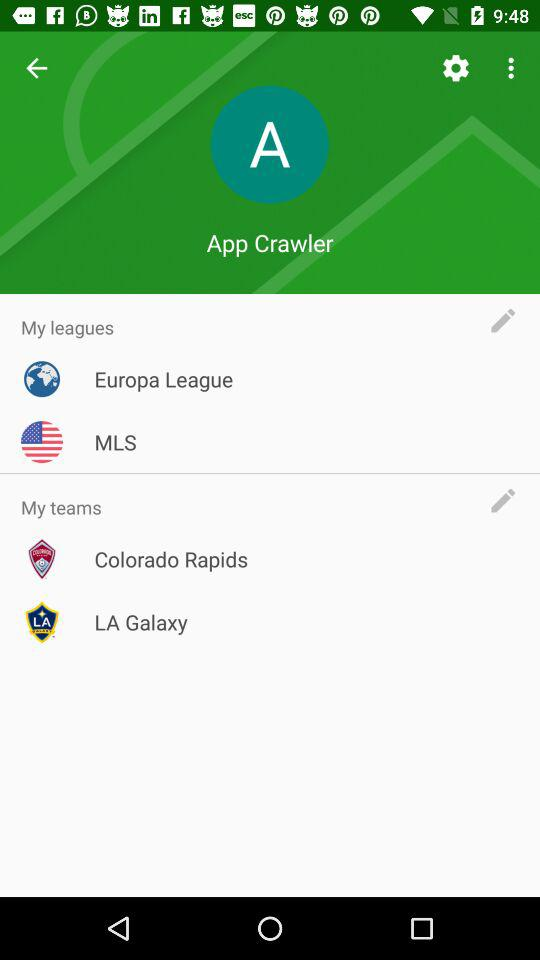What are the names of the teams? The names of the teams are "Colorado Rapids" and "LA Galaxy". 